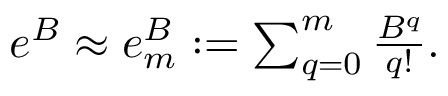Convert formula to latex. <formula><loc_0><loc_0><loc_500><loc_500>\begin{array} { r } { e ^ { B } \approx e _ { m } ^ { B } \colon = \sum _ { q = 0 } ^ { m } \frac { B ^ { q } } { q ! } . } \end{array}</formula> 